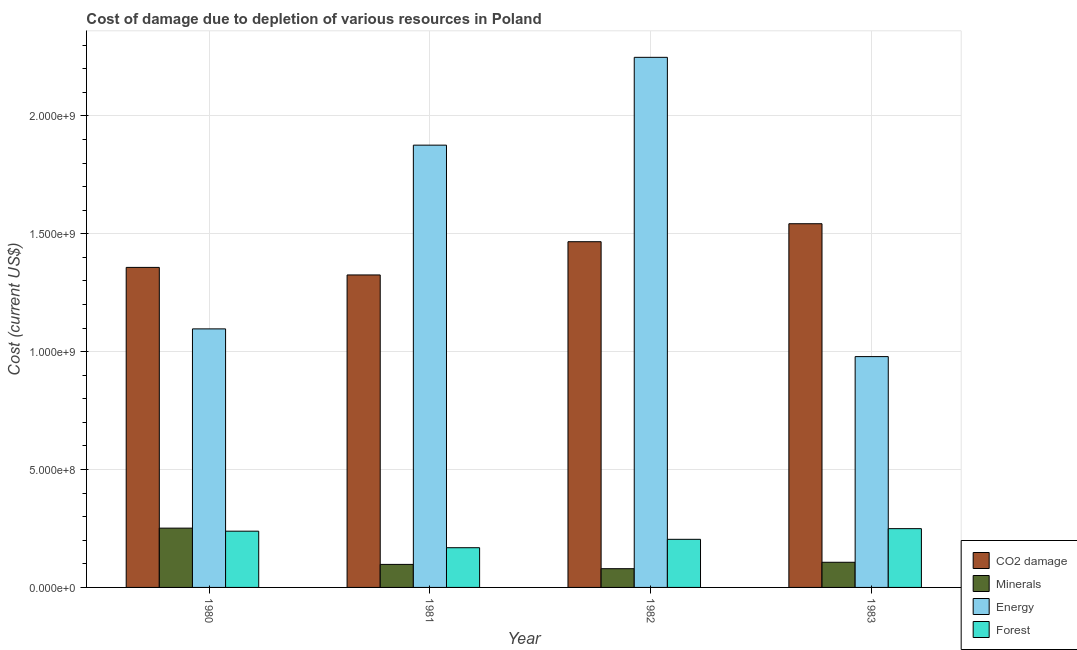How many different coloured bars are there?
Your answer should be very brief. 4. How many bars are there on the 1st tick from the left?
Give a very brief answer. 4. How many bars are there on the 3rd tick from the right?
Your answer should be very brief. 4. What is the cost of damage due to depletion of coal in 1983?
Ensure brevity in your answer.  1.54e+09. Across all years, what is the maximum cost of damage due to depletion of forests?
Your response must be concise. 2.49e+08. Across all years, what is the minimum cost of damage due to depletion of forests?
Provide a succinct answer. 1.68e+08. What is the total cost of damage due to depletion of forests in the graph?
Make the answer very short. 8.60e+08. What is the difference between the cost of damage due to depletion of coal in 1981 and that in 1982?
Your answer should be compact. -1.41e+08. What is the difference between the cost of damage due to depletion of coal in 1983 and the cost of damage due to depletion of forests in 1980?
Make the answer very short. 1.85e+08. What is the average cost of damage due to depletion of energy per year?
Ensure brevity in your answer.  1.55e+09. In the year 1981, what is the difference between the cost of damage due to depletion of minerals and cost of damage due to depletion of energy?
Provide a succinct answer. 0. In how many years, is the cost of damage due to depletion of energy greater than 1900000000 US$?
Your answer should be very brief. 1. What is the ratio of the cost of damage due to depletion of energy in 1982 to that in 1983?
Keep it short and to the point. 2.3. Is the difference between the cost of damage due to depletion of forests in 1982 and 1983 greater than the difference between the cost of damage due to depletion of coal in 1982 and 1983?
Keep it short and to the point. No. What is the difference between the highest and the second highest cost of damage due to depletion of forests?
Provide a short and direct response. 1.07e+07. What is the difference between the highest and the lowest cost of damage due to depletion of energy?
Provide a succinct answer. 1.27e+09. In how many years, is the cost of damage due to depletion of minerals greater than the average cost of damage due to depletion of minerals taken over all years?
Your answer should be compact. 1. What does the 2nd bar from the left in 1980 represents?
Give a very brief answer. Minerals. What does the 4th bar from the right in 1981 represents?
Make the answer very short. CO2 damage. How many bars are there?
Offer a very short reply. 16. How many years are there in the graph?
Give a very brief answer. 4. What is the difference between two consecutive major ticks on the Y-axis?
Provide a short and direct response. 5.00e+08. Are the values on the major ticks of Y-axis written in scientific E-notation?
Offer a very short reply. Yes. Where does the legend appear in the graph?
Offer a very short reply. Bottom right. How many legend labels are there?
Your answer should be very brief. 4. How are the legend labels stacked?
Offer a terse response. Vertical. What is the title of the graph?
Offer a very short reply. Cost of damage due to depletion of various resources in Poland . What is the label or title of the X-axis?
Offer a terse response. Year. What is the label or title of the Y-axis?
Make the answer very short. Cost (current US$). What is the Cost (current US$) in CO2 damage in 1980?
Give a very brief answer. 1.36e+09. What is the Cost (current US$) of Minerals in 1980?
Your answer should be compact. 2.51e+08. What is the Cost (current US$) of Energy in 1980?
Give a very brief answer. 1.10e+09. What is the Cost (current US$) of Forest in 1980?
Your answer should be very brief. 2.39e+08. What is the Cost (current US$) of CO2 damage in 1981?
Offer a terse response. 1.33e+09. What is the Cost (current US$) of Minerals in 1981?
Your answer should be very brief. 9.77e+07. What is the Cost (current US$) in Energy in 1981?
Provide a succinct answer. 1.88e+09. What is the Cost (current US$) of Forest in 1981?
Provide a short and direct response. 1.68e+08. What is the Cost (current US$) in CO2 damage in 1982?
Your answer should be compact. 1.47e+09. What is the Cost (current US$) in Minerals in 1982?
Offer a terse response. 7.95e+07. What is the Cost (current US$) of Energy in 1982?
Your response must be concise. 2.25e+09. What is the Cost (current US$) of Forest in 1982?
Offer a terse response. 2.04e+08. What is the Cost (current US$) of CO2 damage in 1983?
Provide a short and direct response. 1.54e+09. What is the Cost (current US$) in Minerals in 1983?
Provide a short and direct response. 1.07e+08. What is the Cost (current US$) of Energy in 1983?
Provide a succinct answer. 9.79e+08. What is the Cost (current US$) of Forest in 1983?
Provide a succinct answer. 2.49e+08. Across all years, what is the maximum Cost (current US$) in CO2 damage?
Ensure brevity in your answer.  1.54e+09. Across all years, what is the maximum Cost (current US$) of Minerals?
Your answer should be very brief. 2.51e+08. Across all years, what is the maximum Cost (current US$) of Energy?
Offer a very short reply. 2.25e+09. Across all years, what is the maximum Cost (current US$) in Forest?
Provide a short and direct response. 2.49e+08. Across all years, what is the minimum Cost (current US$) of CO2 damage?
Your answer should be compact. 1.33e+09. Across all years, what is the minimum Cost (current US$) of Minerals?
Ensure brevity in your answer.  7.95e+07. Across all years, what is the minimum Cost (current US$) in Energy?
Make the answer very short. 9.79e+08. Across all years, what is the minimum Cost (current US$) of Forest?
Offer a terse response. 1.68e+08. What is the total Cost (current US$) of CO2 damage in the graph?
Your answer should be very brief. 5.69e+09. What is the total Cost (current US$) of Minerals in the graph?
Your response must be concise. 5.35e+08. What is the total Cost (current US$) of Energy in the graph?
Ensure brevity in your answer.  6.20e+09. What is the total Cost (current US$) in Forest in the graph?
Offer a very short reply. 8.60e+08. What is the difference between the Cost (current US$) of CO2 damage in 1980 and that in 1981?
Offer a terse response. 3.20e+07. What is the difference between the Cost (current US$) of Minerals in 1980 and that in 1981?
Provide a short and direct response. 1.54e+08. What is the difference between the Cost (current US$) of Energy in 1980 and that in 1981?
Your answer should be very brief. -7.79e+08. What is the difference between the Cost (current US$) in Forest in 1980 and that in 1981?
Your response must be concise. 7.01e+07. What is the difference between the Cost (current US$) of CO2 damage in 1980 and that in 1982?
Your answer should be very brief. -1.09e+08. What is the difference between the Cost (current US$) in Minerals in 1980 and that in 1982?
Your answer should be compact. 1.72e+08. What is the difference between the Cost (current US$) in Energy in 1980 and that in 1982?
Give a very brief answer. -1.15e+09. What is the difference between the Cost (current US$) in Forest in 1980 and that in 1982?
Make the answer very short. 3.46e+07. What is the difference between the Cost (current US$) in CO2 damage in 1980 and that in 1983?
Give a very brief answer. -1.85e+08. What is the difference between the Cost (current US$) in Minerals in 1980 and that in 1983?
Provide a succinct answer. 1.45e+08. What is the difference between the Cost (current US$) of Energy in 1980 and that in 1983?
Give a very brief answer. 1.18e+08. What is the difference between the Cost (current US$) of Forest in 1980 and that in 1983?
Keep it short and to the point. -1.07e+07. What is the difference between the Cost (current US$) of CO2 damage in 1981 and that in 1982?
Give a very brief answer. -1.41e+08. What is the difference between the Cost (current US$) of Minerals in 1981 and that in 1982?
Your response must be concise. 1.82e+07. What is the difference between the Cost (current US$) of Energy in 1981 and that in 1982?
Keep it short and to the point. -3.72e+08. What is the difference between the Cost (current US$) in Forest in 1981 and that in 1982?
Make the answer very short. -3.55e+07. What is the difference between the Cost (current US$) of CO2 damage in 1981 and that in 1983?
Give a very brief answer. -2.17e+08. What is the difference between the Cost (current US$) in Minerals in 1981 and that in 1983?
Ensure brevity in your answer.  -9.02e+06. What is the difference between the Cost (current US$) in Energy in 1981 and that in 1983?
Your answer should be compact. 8.97e+08. What is the difference between the Cost (current US$) of Forest in 1981 and that in 1983?
Provide a succinct answer. -8.08e+07. What is the difference between the Cost (current US$) in CO2 damage in 1982 and that in 1983?
Offer a terse response. -7.63e+07. What is the difference between the Cost (current US$) of Minerals in 1982 and that in 1983?
Keep it short and to the point. -2.72e+07. What is the difference between the Cost (current US$) in Energy in 1982 and that in 1983?
Ensure brevity in your answer.  1.27e+09. What is the difference between the Cost (current US$) of Forest in 1982 and that in 1983?
Make the answer very short. -4.53e+07. What is the difference between the Cost (current US$) in CO2 damage in 1980 and the Cost (current US$) in Minerals in 1981?
Your response must be concise. 1.26e+09. What is the difference between the Cost (current US$) of CO2 damage in 1980 and the Cost (current US$) of Energy in 1981?
Your answer should be very brief. -5.19e+08. What is the difference between the Cost (current US$) in CO2 damage in 1980 and the Cost (current US$) in Forest in 1981?
Provide a succinct answer. 1.19e+09. What is the difference between the Cost (current US$) in Minerals in 1980 and the Cost (current US$) in Energy in 1981?
Give a very brief answer. -1.62e+09. What is the difference between the Cost (current US$) of Minerals in 1980 and the Cost (current US$) of Forest in 1981?
Provide a succinct answer. 8.30e+07. What is the difference between the Cost (current US$) of Energy in 1980 and the Cost (current US$) of Forest in 1981?
Offer a terse response. 9.28e+08. What is the difference between the Cost (current US$) in CO2 damage in 1980 and the Cost (current US$) in Minerals in 1982?
Provide a succinct answer. 1.28e+09. What is the difference between the Cost (current US$) of CO2 damage in 1980 and the Cost (current US$) of Energy in 1982?
Offer a very short reply. -8.91e+08. What is the difference between the Cost (current US$) in CO2 damage in 1980 and the Cost (current US$) in Forest in 1982?
Your answer should be very brief. 1.15e+09. What is the difference between the Cost (current US$) in Minerals in 1980 and the Cost (current US$) in Energy in 1982?
Make the answer very short. -2.00e+09. What is the difference between the Cost (current US$) of Minerals in 1980 and the Cost (current US$) of Forest in 1982?
Your answer should be very brief. 4.75e+07. What is the difference between the Cost (current US$) in Energy in 1980 and the Cost (current US$) in Forest in 1982?
Provide a succinct answer. 8.93e+08. What is the difference between the Cost (current US$) in CO2 damage in 1980 and the Cost (current US$) in Minerals in 1983?
Provide a short and direct response. 1.25e+09. What is the difference between the Cost (current US$) of CO2 damage in 1980 and the Cost (current US$) of Energy in 1983?
Offer a very short reply. 3.78e+08. What is the difference between the Cost (current US$) in CO2 damage in 1980 and the Cost (current US$) in Forest in 1983?
Give a very brief answer. 1.11e+09. What is the difference between the Cost (current US$) in Minerals in 1980 and the Cost (current US$) in Energy in 1983?
Your answer should be very brief. -7.28e+08. What is the difference between the Cost (current US$) of Minerals in 1980 and the Cost (current US$) of Forest in 1983?
Your answer should be compact. 2.17e+06. What is the difference between the Cost (current US$) in Energy in 1980 and the Cost (current US$) in Forest in 1983?
Provide a short and direct response. 8.47e+08. What is the difference between the Cost (current US$) in CO2 damage in 1981 and the Cost (current US$) in Minerals in 1982?
Keep it short and to the point. 1.25e+09. What is the difference between the Cost (current US$) of CO2 damage in 1981 and the Cost (current US$) of Energy in 1982?
Keep it short and to the point. -9.23e+08. What is the difference between the Cost (current US$) of CO2 damage in 1981 and the Cost (current US$) of Forest in 1982?
Give a very brief answer. 1.12e+09. What is the difference between the Cost (current US$) of Minerals in 1981 and the Cost (current US$) of Energy in 1982?
Give a very brief answer. -2.15e+09. What is the difference between the Cost (current US$) in Minerals in 1981 and the Cost (current US$) in Forest in 1982?
Your answer should be compact. -1.06e+08. What is the difference between the Cost (current US$) in Energy in 1981 and the Cost (current US$) in Forest in 1982?
Make the answer very short. 1.67e+09. What is the difference between the Cost (current US$) of CO2 damage in 1981 and the Cost (current US$) of Minerals in 1983?
Ensure brevity in your answer.  1.22e+09. What is the difference between the Cost (current US$) of CO2 damage in 1981 and the Cost (current US$) of Energy in 1983?
Offer a terse response. 3.46e+08. What is the difference between the Cost (current US$) of CO2 damage in 1981 and the Cost (current US$) of Forest in 1983?
Ensure brevity in your answer.  1.08e+09. What is the difference between the Cost (current US$) of Minerals in 1981 and the Cost (current US$) of Energy in 1983?
Give a very brief answer. -8.81e+08. What is the difference between the Cost (current US$) of Minerals in 1981 and the Cost (current US$) of Forest in 1983?
Keep it short and to the point. -1.52e+08. What is the difference between the Cost (current US$) in Energy in 1981 and the Cost (current US$) in Forest in 1983?
Offer a terse response. 1.63e+09. What is the difference between the Cost (current US$) in CO2 damage in 1982 and the Cost (current US$) in Minerals in 1983?
Ensure brevity in your answer.  1.36e+09. What is the difference between the Cost (current US$) of CO2 damage in 1982 and the Cost (current US$) of Energy in 1983?
Your answer should be compact. 4.87e+08. What is the difference between the Cost (current US$) in CO2 damage in 1982 and the Cost (current US$) in Forest in 1983?
Ensure brevity in your answer.  1.22e+09. What is the difference between the Cost (current US$) in Minerals in 1982 and the Cost (current US$) in Energy in 1983?
Your answer should be very brief. -9.00e+08. What is the difference between the Cost (current US$) of Minerals in 1982 and the Cost (current US$) of Forest in 1983?
Your response must be concise. -1.70e+08. What is the difference between the Cost (current US$) in Energy in 1982 and the Cost (current US$) in Forest in 1983?
Ensure brevity in your answer.  2.00e+09. What is the average Cost (current US$) of CO2 damage per year?
Provide a succinct answer. 1.42e+09. What is the average Cost (current US$) of Minerals per year?
Offer a very short reply. 1.34e+08. What is the average Cost (current US$) of Energy per year?
Offer a terse response. 1.55e+09. What is the average Cost (current US$) of Forest per year?
Provide a succinct answer. 2.15e+08. In the year 1980, what is the difference between the Cost (current US$) of CO2 damage and Cost (current US$) of Minerals?
Your response must be concise. 1.11e+09. In the year 1980, what is the difference between the Cost (current US$) in CO2 damage and Cost (current US$) in Energy?
Provide a succinct answer. 2.61e+08. In the year 1980, what is the difference between the Cost (current US$) in CO2 damage and Cost (current US$) in Forest?
Offer a very short reply. 1.12e+09. In the year 1980, what is the difference between the Cost (current US$) in Minerals and Cost (current US$) in Energy?
Keep it short and to the point. -8.45e+08. In the year 1980, what is the difference between the Cost (current US$) in Minerals and Cost (current US$) in Forest?
Keep it short and to the point. 1.29e+07. In the year 1980, what is the difference between the Cost (current US$) of Energy and Cost (current US$) of Forest?
Your answer should be compact. 8.58e+08. In the year 1981, what is the difference between the Cost (current US$) of CO2 damage and Cost (current US$) of Minerals?
Give a very brief answer. 1.23e+09. In the year 1981, what is the difference between the Cost (current US$) of CO2 damage and Cost (current US$) of Energy?
Keep it short and to the point. -5.51e+08. In the year 1981, what is the difference between the Cost (current US$) of CO2 damage and Cost (current US$) of Forest?
Your response must be concise. 1.16e+09. In the year 1981, what is the difference between the Cost (current US$) in Minerals and Cost (current US$) in Energy?
Offer a very short reply. -1.78e+09. In the year 1981, what is the difference between the Cost (current US$) in Minerals and Cost (current US$) in Forest?
Provide a succinct answer. -7.08e+07. In the year 1981, what is the difference between the Cost (current US$) of Energy and Cost (current US$) of Forest?
Your response must be concise. 1.71e+09. In the year 1982, what is the difference between the Cost (current US$) in CO2 damage and Cost (current US$) in Minerals?
Your answer should be very brief. 1.39e+09. In the year 1982, what is the difference between the Cost (current US$) of CO2 damage and Cost (current US$) of Energy?
Give a very brief answer. -7.82e+08. In the year 1982, what is the difference between the Cost (current US$) of CO2 damage and Cost (current US$) of Forest?
Your response must be concise. 1.26e+09. In the year 1982, what is the difference between the Cost (current US$) of Minerals and Cost (current US$) of Energy?
Provide a short and direct response. -2.17e+09. In the year 1982, what is the difference between the Cost (current US$) in Minerals and Cost (current US$) in Forest?
Your answer should be compact. -1.25e+08. In the year 1982, what is the difference between the Cost (current US$) of Energy and Cost (current US$) of Forest?
Offer a terse response. 2.04e+09. In the year 1983, what is the difference between the Cost (current US$) in CO2 damage and Cost (current US$) in Minerals?
Offer a terse response. 1.44e+09. In the year 1983, what is the difference between the Cost (current US$) in CO2 damage and Cost (current US$) in Energy?
Make the answer very short. 5.64e+08. In the year 1983, what is the difference between the Cost (current US$) of CO2 damage and Cost (current US$) of Forest?
Keep it short and to the point. 1.29e+09. In the year 1983, what is the difference between the Cost (current US$) in Minerals and Cost (current US$) in Energy?
Offer a terse response. -8.72e+08. In the year 1983, what is the difference between the Cost (current US$) in Minerals and Cost (current US$) in Forest?
Offer a very short reply. -1.43e+08. In the year 1983, what is the difference between the Cost (current US$) in Energy and Cost (current US$) in Forest?
Give a very brief answer. 7.30e+08. What is the ratio of the Cost (current US$) of CO2 damage in 1980 to that in 1981?
Offer a terse response. 1.02. What is the ratio of the Cost (current US$) in Minerals in 1980 to that in 1981?
Provide a short and direct response. 2.57. What is the ratio of the Cost (current US$) in Energy in 1980 to that in 1981?
Keep it short and to the point. 0.58. What is the ratio of the Cost (current US$) of Forest in 1980 to that in 1981?
Keep it short and to the point. 1.42. What is the ratio of the Cost (current US$) in CO2 damage in 1980 to that in 1982?
Make the answer very short. 0.93. What is the ratio of the Cost (current US$) in Minerals in 1980 to that in 1982?
Make the answer very short. 3.16. What is the ratio of the Cost (current US$) in Energy in 1980 to that in 1982?
Offer a terse response. 0.49. What is the ratio of the Cost (current US$) of Forest in 1980 to that in 1982?
Offer a very short reply. 1.17. What is the ratio of the Cost (current US$) in CO2 damage in 1980 to that in 1983?
Offer a terse response. 0.88. What is the ratio of the Cost (current US$) in Minerals in 1980 to that in 1983?
Give a very brief answer. 2.36. What is the ratio of the Cost (current US$) in Energy in 1980 to that in 1983?
Provide a succinct answer. 1.12. What is the ratio of the Cost (current US$) in Forest in 1980 to that in 1983?
Your response must be concise. 0.96. What is the ratio of the Cost (current US$) of CO2 damage in 1981 to that in 1982?
Ensure brevity in your answer.  0.9. What is the ratio of the Cost (current US$) of Minerals in 1981 to that in 1982?
Offer a very short reply. 1.23. What is the ratio of the Cost (current US$) of Energy in 1981 to that in 1982?
Make the answer very short. 0.83. What is the ratio of the Cost (current US$) of Forest in 1981 to that in 1982?
Your answer should be very brief. 0.83. What is the ratio of the Cost (current US$) of CO2 damage in 1981 to that in 1983?
Make the answer very short. 0.86. What is the ratio of the Cost (current US$) of Minerals in 1981 to that in 1983?
Your answer should be compact. 0.92. What is the ratio of the Cost (current US$) in Energy in 1981 to that in 1983?
Make the answer very short. 1.92. What is the ratio of the Cost (current US$) in Forest in 1981 to that in 1983?
Keep it short and to the point. 0.68. What is the ratio of the Cost (current US$) of CO2 damage in 1982 to that in 1983?
Your response must be concise. 0.95. What is the ratio of the Cost (current US$) of Minerals in 1982 to that in 1983?
Keep it short and to the point. 0.74. What is the ratio of the Cost (current US$) in Energy in 1982 to that in 1983?
Your answer should be very brief. 2.3. What is the ratio of the Cost (current US$) in Forest in 1982 to that in 1983?
Your answer should be very brief. 0.82. What is the difference between the highest and the second highest Cost (current US$) of CO2 damage?
Provide a short and direct response. 7.63e+07. What is the difference between the highest and the second highest Cost (current US$) of Minerals?
Your answer should be compact. 1.45e+08. What is the difference between the highest and the second highest Cost (current US$) of Energy?
Offer a terse response. 3.72e+08. What is the difference between the highest and the second highest Cost (current US$) in Forest?
Your response must be concise. 1.07e+07. What is the difference between the highest and the lowest Cost (current US$) in CO2 damage?
Give a very brief answer. 2.17e+08. What is the difference between the highest and the lowest Cost (current US$) of Minerals?
Give a very brief answer. 1.72e+08. What is the difference between the highest and the lowest Cost (current US$) of Energy?
Ensure brevity in your answer.  1.27e+09. What is the difference between the highest and the lowest Cost (current US$) of Forest?
Your answer should be compact. 8.08e+07. 